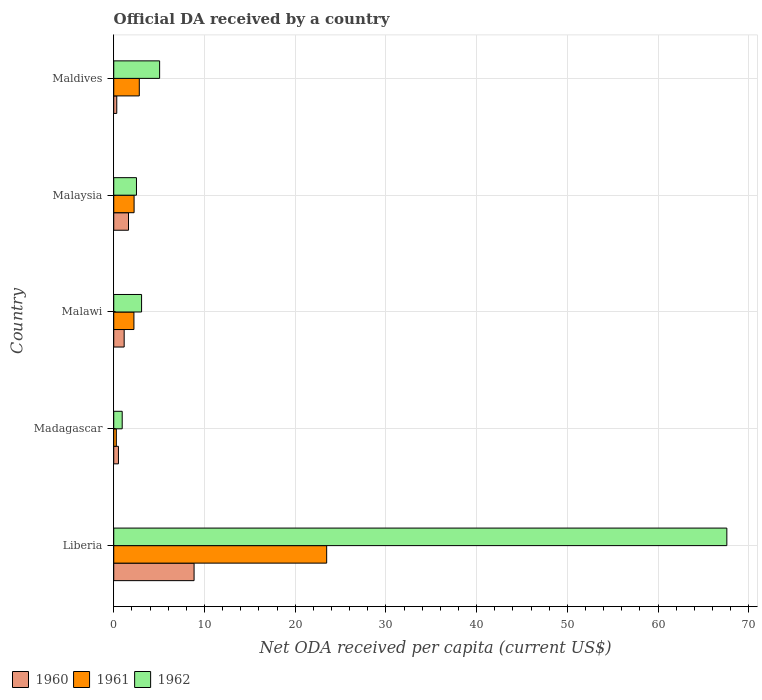How many different coloured bars are there?
Keep it short and to the point. 3. How many bars are there on the 5th tick from the top?
Your answer should be compact. 3. How many bars are there on the 2nd tick from the bottom?
Provide a succinct answer. 3. What is the label of the 1st group of bars from the top?
Ensure brevity in your answer.  Maldives. In how many cases, is the number of bars for a given country not equal to the number of legend labels?
Offer a very short reply. 0. What is the ODA received in in 1961 in Malaysia?
Your answer should be compact. 2.24. Across all countries, what is the maximum ODA received in in 1960?
Keep it short and to the point. 8.85. Across all countries, what is the minimum ODA received in in 1960?
Give a very brief answer. 0.33. In which country was the ODA received in in 1961 maximum?
Offer a terse response. Liberia. In which country was the ODA received in in 1962 minimum?
Offer a terse response. Madagascar. What is the total ODA received in in 1960 in the graph?
Your answer should be compact. 12.49. What is the difference between the ODA received in in 1961 in Madagascar and that in Malawi?
Provide a succinct answer. -1.94. What is the difference between the ODA received in in 1961 in Maldives and the ODA received in in 1962 in Madagascar?
Keep it short and to the point. 1.88. What is the average ODA received in in 1962 per country?
Your response must be concise. 15.83. What is the difference between the ODA received in in 1962 and ODA received in in 1960 in Madagascar?
Your answer should be very brief. 0.41. What is the ratio of the ODA received in in 1962 in Liberia to that in Madagascar?
Keep it short and to the point. 72.49. What is the difference between the highest and the second highest ODA received in in 1962?
Your answer should be very brief. 62.52. What is the difference between the highest and the lowest ODA received in in 1961?
Your response must be concise. 23.18. Is the sum of the ODA received in in 1962 in Madagascar and Malawi greater than the maximum ODA received in in 1960 across all countries?
Offer a very short reply. No. Is it the case that in every country, the sum of the ODA received in in 1961 and ODA received in in 1962 is greater than the ODA received in in 1960?
Make the answer very short. Yes. How many bars are there?
Offer a terse response. 15. How many countries are there in the graph?
Ensure brevity in your answer.  5. What is the difference between two consecutive major ticks on the X-axis?
Keep it short and to the point. 10. Are the values on the major ticks of X-axis written in scientific E-notation?
Offer a terse response. No. Where does the legend appear in the graph?
Your answer should be very brief. Bottom left. How are the legend labels stacked?
Provide a short and direct response. Horizontal. What is the title of the graph?
Offer a terse response. Official DA received by a country. What is the label or title of the X-axis?
Offer a very short reply. Net ODA received per capita (current US$). What is the label or title of the Y-axis?
Make the answer very short. Country. What is the Net ODA received per capita (current US$) of 1960 in Liberia?
Ensure brevity in your answer.  8.85. What is the Net ODA received per capita (current US$) of 1961 in Liberia?
Offer a terse response. 23.47. What is the Net ODA received per capita (current US$) in 1962 in Liberia?
Offer a very short reply. 67.57. What is the Net ODA received per capita (current US$) of 1960 in Madagascar?
Your answer should be compact. 0.52. What is the Net ODA received per capita (current US$) of 1961 in Madagascar?
Keep it short and to the point. 0.29. What is the Net ODA received per capita (current US$) in 1962 in Madagascar?
Keep it short and to the point. 0.93. What is the Net ODA received per capita (current US$) of 1960 in Malawi?
Keep it short and to the point. 1.15. What is the Net ODA received per capita (current US$) in 1961 in Malawi?
Offer a very short reply. 2.22. What is the Net ODA received per capita (current US$) in 1962 in Malawi?
Make the answer very short. 3.07. What is the Net ODA received per capita (current US$) in 1960 in Malaysia?
Give a very brief answer. 1.63. What is the Net ODA received per capita (current US$) in 1961 in Malaysia?
Your answer should be very brief. 2.24. What is the Net ODA received per capita (current US$) in 1962 in Malaysia?
Keep it short and to the point. 2.5. What is the Net ODA received per capita (current US$) in 1960 in Maldives?
Make the answer very short. 0.33. What is the Net ODA received per capita (current US$) of 1961 in Maldives?
Offer a very short reply. 2.82. What is the Net ODA received per capita (current US$) in 1962 in Maldives?
Ensure brevity in your answer.  5.06. Across all countries, what is the maximum Net ODA received per capita (current US$) of 1960?
Ensure brevity in your answer.  8.85. Across all countries, what is the maximum Net ODA received per capita (current US$) in 1961?
Give a very brief answer. 23.47. Across all countries, what is the maximum Net ODA received per capita (current US$) of 1962?
Give a very brief answer. 67.57. Across all countries, what is the minimum Net ODA received per capita (current US$) of 1960?
Your response must be concise. 0.33. Across all countries, what is the minimum Net ODA received per capita (current US$) of 1961?
Ensure brevity in your answer.  0.29. Across all countries, what is the minimum Net ODA received per capita (current US$) of 1962?
Give a very brief answer. 0.93. What is the total Net ODA received per capita (current US$) in 1960 in the graph?
Offer a terse response. 12.48. What is the total Net ODA received per capita (current US$) in 1961 in the graph?
Your response must be concise. 31.04. What is the total Net ODA received per capita (current US$) of 1962 in the graph?
Offer a terse response. 79.14. What is the difference between the Net ODA received per capita (current US$) of 1960 in Liberia and that in Madagascar?
Your answer should be compact. 8.34. What is the difference between the Net ODA received per capita (current US$) in 1961 in Liberia and that in Madagascar?
Provide a short and direct response. 23.18. What is the difference between the Net ODA received per capita (current US$) of 1962 in Liberia and that in Madagascar?
Ensure brevity in your answer.  66.64. What is the difference between the Net ODA received per capita (current US$) in 1960 in Liberia and that in Malawi?
Provide a succinct answer. 7.71. What is the difference between the Net ODA received per capita (current US$) of 1961 in Liberia and that in Malawi?
Your answer should be compact. 21.25. What is the difference between the Net ODA received per capita (current US$) in 1962 in Liberia and that in Malawi?
Offer a very short reply. 64.51. What is the difference between the Net ODA received per capita (current US$) of 1960 in Liberia and that in Malaysia?
Your response must be concise. 7.23. What is the difference between the Net ODA received per capita (current US$) of 1961 in Liberia and that in Malaysia?
Ensure brevity in your answer.  21.23. What is the difference between the Net ODA received per capita (current US$) of 1962 in Liberia and that in Malaysia?
Your answer should be compact. 65.07. What is the difference between the Net ODA received per capita (current US$) in 1960 in Liberia and that in Maldives?
Provide a succinct answer. 8.52. What is the difference between the Net ODA received per capita (current US$) of 1961 in Liberia and that in Maldives?
Keep it short and to the point. 20.65. What is the difference between the Net ODA received per capita (current US$) of 1962 in Liberia and that in Maldives?
Your answer should be very brief. 62.52. What is the difference between the Net ODA received per capita (current US$) in 1960 in Madagascar and that in Malawi?
Your response must be concise. -0.63. What is the difference between the Net ODA received per capita (current US$) of 1961 in Madagascar and that in Malawi?
Your answer should be compact. -1.94. What is the difference between the Net ODA received per capita (current US$) in 1962 in Madagascar and that in Malawi?
Provide a short and direct response. -2.14. What is the difference between the Net ODA received per capita (current US$) of 1960 in Madagascar and that in Malaysia?
Give a very brief answer. -1.11. What is the difference between the Net ODA received per capita (current US$) of 1961 in Madagascar and that in Malaysia?
Keep it short and to the point. -1.96. What is the difference between the Net ODA received per capita (current US$) in 1962 in Madagascar and that in Malaysia?
Your answer should be very brief. -1.57. What is the difference between the Net ODA received per capita (current US$) in 1960 in Madagascar and that in Maldives?
Keep it short and to the point. 0.19. What is the difference between the Net ODA received per capita (current US$) in 1961 in Madagascar and that in Maldives?
Provide a succinct answer. -2.53. What is the difference between the Net ODA received per capita (current US$) in 1962 in Madagascar and that in Maldives?
Provide a succinct answer. -4.13. What is the difference between the Net ODA received per capita (current US$) in 1960 in Malawi and that in Malaysia?
Ensure brevity in your answer.  -0.48. What is the difference between the Net ODA received per capita (current US$) in 1961 in Malawi and that in Malaysia?
Give a very brief answer. -0.02. What is the difference between the Net ODA received per capita (current US$) in 1962 in Malawi and that in Malaysia?
Keep it short and to the point. 0.56. What is the difference between the Net ODA received per capita (current US$) of 1960 in Malawi and that in Maldives?
Your answer should be compact. 0.82. What is the difference between the Net ODA received per capita (current US$) of 1961 in Malawi and that in Maldives?
Your response must be concise. -0.59. What is the difference between the Net ODA received per capita (current US$) of 1962 in Malawi and that in Maldives?
Your answer should be compact. -1.99. What is the difference between the Net ODA received per capita (current US$) of 1960 in Malaysia and that in Maldives?
Give a very brief answer. 1.29. What is the difference between the Net ODA received per capita (current US$) of 1961 in Malaysia and that in Maldives?
Make the answer very short. -0.57. What is the difference between the Net ODA received per capita (current US$) in 1962 in Malaysia and that in Maldives?
Your response must be concise. -2.55. What is the difference between the Net ODA received per capita (current US$) of 1960 in Liberia and the Net ODA received per capita (current US$) of 1961 in Madagascar?
Make the answer very short. 8.57. What is the difference between the Net ODA received per capita (current US$) in 1960 in Liberia and the Net ODA received per capita (current US$) in 1962 in Madagascar?
Provide a succinct answer. 7.92. What is the difference between the Net ODA received per capita (current US$) of 1961 in Liberia and the Net ODA received per capita (current US$) of 1962 in Madagascar?
Give a very brief answer. 22.54. What is the difference between the Net ODA received per capita (current US$) of 1960 in Liberia and the Net ODA received per capita (current US$) of 1961 in Malawi?
Provide a short and direct response. 6.63. What is the difference between the Net ODA received per capita (current US$) in 1960 in Liberia and the Net ODA received per capita (current US$) in 1962 in Malawi?
Your response must be concise. 5.79. What is the difference between the Net ODA received per capita (current US$) of 1961 in Liberia and the Net ODA received per capita (current US$) of 1962 in Malawi?
Your answer should be very brief. 20.4. What is the difference between the Net ODA received per capita (current US$) of 1960 in Liberia and the Net ODA received per capita (current US$) of 1961 in Malaysia?
Offer a terse response. 6.61. What is the difference between the Net ODA received per capita (current US$) in 1960 in Liberia and the Net ODA received per capita (current US$) in 1962 in Malaysia?
Ensure brevity in your answer.  6.35. What is the difference between the Net ODA received per capita (current US$) in 1961 in Liberia and the Net ODA received per capita (current US$) in 1962 in Malaysia?
Give a very brief answer. 20.96. What is the difference between the Net ODA received per capita (current US$) of 1960 in Liberia and the Net ODA received per capita (current US$) of 1961 in Maldives?
Ensure brevity in your answer.  6.04. What is the difference between the Net ODA received per capita (current US$) in 1960 in Liberia and the Net ODA received per capita (current US$) in 1962 in Maldives?
Provide a short and direct response. 3.8. What is the difference between the Net ODA received per capita (current US$) of 1961 in Liberia and the Net ODA received per capita (current US$) of 1962 in Maldives?
Provide a short and direct response. 18.41. What is the difference between the Net ODA received per capita (current US$) in 1960 in Madagascar and the Net ODA received per capita (current US$) in 1961 in Malawi?
Offer a terse response. -1.7. What is the difference between the Net ODA received per capita (current US$) in 1960 in Madagascar and the Net ODA received per capita (current US$) in 1962 in Malawi?
Your answer should be very brief. -2.55. What is the difference between the Net ODA received per capita (current US$) in 1961 in Madagascar and the Net ODA received per capita (current US$) in 1962 in Malawi?
Offer a very short reply. -2.78. What is the difference between the Net ODA received per capita (current US$) in 1960 in Madagascar and the Net ODA received per capita (current US$) in 1961 in Malaysia?
Provide a succinct answer. -1.72. What is the difference between the Net ODA received per capita (current US$) of 1960 in Madagascar and the Net ODA received per capita (current US$) of 1962 in Malaysia?
Provide a short and direct response. -1.99. What is the difference between the Net ODA received per capita (current US$) of 1961 in Madagascar and the Net ODA received per capita (current US$) of 1962 in Malaysia?
Offer a terse response. -2.22. What is the difference between the Net ODA received per capita (current US$) of 1960 in Madagascar and the Net ODA received per capita (current US$) of 1961 in Maldives?
Offer a terse response. -2.3. What is the difference between the Net ODA received per capita (current US$) of 1960 in Madagascar and the Net ODA received per capita (current US$) of 1962 in Maldives?
Your answer should be very brief. -4.54. What is the difference between the Net ODA received per capita (current US$) of 1961 in Madagascar and the Net ODA received per capita (current US$) of 1962 in Maldives?
Make the answer very short. -4.77. What is the difference between the Net ODA received per capita (current US$) of 1960 in Malawi and the Net ODA received per capita (current US$) of 1961 in Malaysia?
Your answer should be very brief. -1.09. What is the difference between the Net ODA received per capita (current US$) in 1960 in Malawi and the Net ODA received per capita (current US$) in 1962 in Malaysia?
Ensure brevity in your answer.  -1.36. What is the difference between the Net ODA received per capita (current US$) in 1961 in Malawi and the Net ODA received per capita (current US$) in 1962 in Malaysia?
Ensure brevity in your answer.  -0.28. What is the difference between the Net ODA received per capita (current US$) in 1960 in Malawi and the Net ODA received per capita (current US$) in 1961 in Maldives?
Offer a very short reply. -1.67. What is the difference between the Net ODA received per capita (current US$) of 1960 in Malawi and the Net ODA received per capita (current US$) of 1962 in Maldives?
Offer a very short reply. -3.91. What is the difference between the Net ODA received per capita (current US$) of 1961 in Malawi and the Net ODA received per capita (current US$) of 1962 in Maldives?
Offer a very short reply. -2.83. What is the difference between the Net ODA received per capita (current US$) in 1960 in Malaysia and the Net ODA received per capita (current US$) in 1961 in Maldives?
Offer a terse response. -1.19. What is the difference between the Net ODA received per capita (current US$) in 1960 in Malaysia and the Net ODA received per capita (current US$) in 1962 in Maldives?
Your response must be concise. -3.43. What is the difference between the Net ODA received per capita (current US$) of 1961 in Malaysia and the Net ODA received per capita (current US$) of 1962 in Maldives?
Your answer should be very brief. -2.81. What is the average Net ODA received per capita (current US$) of 1960 per country?
Offer a very short reply. 2.5. What is the average Net ODA received per capita (current US$) of 1961 per country?
Keep it short and to the point. 6.21. What is the average Net ODA received per capita (current US$) of 1962 per country?
Offer a terse response. 15.83. What is the difference between the Net ODA received per capita (current US$) in 1960 and Net ODA received per capita (current US$) in 1961 in Liberia?
Ensure brevity in your answer.  -14.61. What is the difference between the Net ODA received per capita (current US$) of 1960 and Net ODA received per capita (current US$) of 1962 in Liberia?
Your response must be concise. -58.72. What is the difference between the Net ODA received per capita (current US$) of 1961 and Net ODA received per capita (current US$) of 1962 in Liberia?
Your answer should be compact. -44.1. What is the difference between the Net ODA received per capita (current US$) in 1960 and Net ODA received per capita (current US$) in 1961 in Madagascar?
Your answer should be very brief. 0.23. What is the difference between the Net ODA received per capita (current US$) in 1960 and Net ODA received per capita (current US$) in 1962 in Madagascar?
Offer a very short reply. -0.41. What is the difference between the Net ODA received per capita (current US$) in 1961 and Net ODA received per capita (current US$) in 1962 in Madagascar?
Make the answer very short. -0.65. What is the difference between the Net ODA received per capita (current US$) in 1960 and Net ODA received per capita (current US$) in 1961 in Malawi?
Make the answer very short. -1.07. What is the difference between the Net ODA received per capita (current US$) in 1960 and Net ODA received per capita (current US$) in 1962 in Malawi?
Provide a succinct answer. -1.92. What is the difference between the Net ODA received per capita (current US$) of 1961 and Net ODA received per capita (current US$) of 1962 in Malawi?
Keep it short and to the point. -0.84. What is the difference between the Net ODA received per capita (current US$) in 1960 and Net ODA received per capita (current US$) in 1961 in Malaysia?
Your answer should be very brief. -0.62. What is the difference between the Net ODA received per capita (current US$) in 1960 and Net ODA received per capita (current US$) in 1962 in Malaysia?
Keep it short and to the point. -0.88. What is the difference between the Net ODA received per capita (current US$) of 1961 and Net ODA received per capita (current US$) of 1962 in Malaysia?
Offer a very short reply. -0.26. What is the difference between the Net ODA received per capita (current US$) in 1960 and Net ODA received per capita (current US$) in 1961 in Maldives?
Make the answer very short. -2.48. What is the difference between the Net ODA received per capita (current US$) in 1960 and Net ODA received per capita (current US$) in 1962 in Maldives?
Provide a succinct answer. -4.72. What is the difference between the Net ODA received per capita (current US$) of 1961 and Net ODA received per capita (current US$) of 1962 in Maldives?
Offer a terse response. -2.24. What is the ratio of the Net ODA received per capita (current US$) of 1960 in Liberia to that in Madagascar?
Ensure brevity in your answer.  17.04. What is the ratio of the Net ODA received per capita (current US$) in 1961 in Liberia to that in Madagascar?
Make the answer very short. 82.28. What is the ratio of the Net ODA received per capita (current US$) in 1962 in Liberia to that in Madagascar?
Provide a short and direct response. 72.49. What is the ratio of the Net ODA received per capita (current US$) of 1960 in Liberia to that in Malawi?
Provide a short and direct response. 7.7. What is the ratio of the Net ODA received per capita (current US$) of 1961 in Liberia to that in Malawi?
Your response must be concise. 10.55. What is the ratio of the Net ODA received per capita (current US$) in 1962 in Liberia to that in Malawi?
Your answer should be compact. 22.03. What is the ratio of the Net ODA received per capita (current US$) of 1960 in Liberia to that in Malaysia?
Make the answer very short. 5.44. What is the ratio of the Net ODA received per capita (current US$) of 1961 in Liberia to that in Malaysia?
Your answer should be compact. 10.46. What is the ratio of the Net ODA received per capita (current US$) of 1962 in Liberia to that in Malaysia?
Your answer should be very brief. 26.98. What is the ratio of the Net ODA received per capita (current US$) in 1960 in Liberia to that in Maldives?
Your answer should be compact. 26.53. What is the ratio of the Net ODA received per capita (current US$) of 1961 in Liberia to that in Maldives?
Provide a succinct answer. 8.33. What is the ratio of the Net ODA received per capita (current US$) in 1962 in Liberia to that in Maldives?
Your answer should be very brief. 13.36. What is the ratio of the Net ODA received per capita (current US$) of 1960 in Madagascar to that in Malawi?
Provide a succinct answer. 0.45. What is the ratio of the Net ODA received per capita (current US$) of 1961 in Madagascar to that in Malawi?
Offer a terse response. 0.13. What is the ratio of the Net ODA received per capita (current US$) in 1962 in Madagascar to that in Malawi?
Keep it short and to the point. 0.3. What is the ratio of the Net ODA received per capita (current US$) of 1960 in Madagascar to that in Malaysia?
Provide a succinct answer. 0.32. What is the ratio of the Net ODA received per capita (current US$) of 1961 in Madagascar to that in Malaysia?
Your answer should be compact. 0.13. What is the ratio of the Net ODA received per capita (current US$) of 1962 in Madagascar to that in Malaysia?
Offer a very short reply. 0.37. What is the ratio of the Net ODA received per capita (current US$) of 1960 in Madagascar to that in Maldives?
Give a very brief answer. 1.56. What is the ratio of the Net ODA received per capita (current US$) in 1961 in Madagascar to that in Maldives?
Make the answer very short. 0.1. What is the ratio of the Net ODA received per capita (current US$) in 1962 in Madagascar to that in Maldives?
Ensure brevity in your answer.  0.18. What is the ratio of the Net ODA received per capita (current US$) in 1960 in Malawi to that in Malaysia?
Your answer should be compact. 0.71. What is the ratio of the Net ODA received per capita (current US$) of 1961 in Malawi to that in Malaysia?
Your response must be concise. 0.99. What is the ratio of the Net ODA received per capita (current US$) of 1962 in Malawi to that in Malaysia?
Provide a short and direct response. 1.22. What is the ratio of the Net ODA received per capita (current US$) of 1960 in Malawi to that in Maldives?
Provide a short and direct response. 3.44. What is the ratio of the Net ODA received per capita (current US$) of 1961 in Malawi to that in Maldives?
Ensure brevity in your answer.  0.79. What is the ratio of the Net ODA received per capita (current US$) of 1962 in Malawi to that in Maldives?
Keep it short and to the point. 0.61. What is the ratio of the Net ODA received per capita (current US$) of 1960 in Malaysia to that in Maldives?
Ensure brevity in your answer.  4.88. What is the ratio of the Net ODA received per capita (current US$) of 1961 in Malaysia to that in Maldives?
Keep it short and to the point. 0.8. What is the ratio of the Net ODA received per capita (current US$) in 1962 in Malaysia to that in Maldives?
Make the answer very short. 0.5. What is the difference between the highest and the second highest Net ODA received per capita (current US$) in 1960?
Your answer should be very brief. 7.23. What is the difference between the highest and the second highest Net ODA received per capita (current US$) of 1961?
Your answer should be very brief. 20.65. What is the difference between the highest and the second highest Net ODA received per capita (current US$) of 1962?
Your answer should be compact. 62.52. What is the difference between the highest and the lowest Net ODA received per capita (current US$) in 1960?
Keep it short and to the point. 8.52. What is the difference between the highest and the lowest Net ODA received per capita (current US$) in 1961?
Give a very brief answer. 23.18. What is the difference between the highest and the lowest Net ODA received per capita (current US$) of 1962?
Your response must be concise. 66.64. 